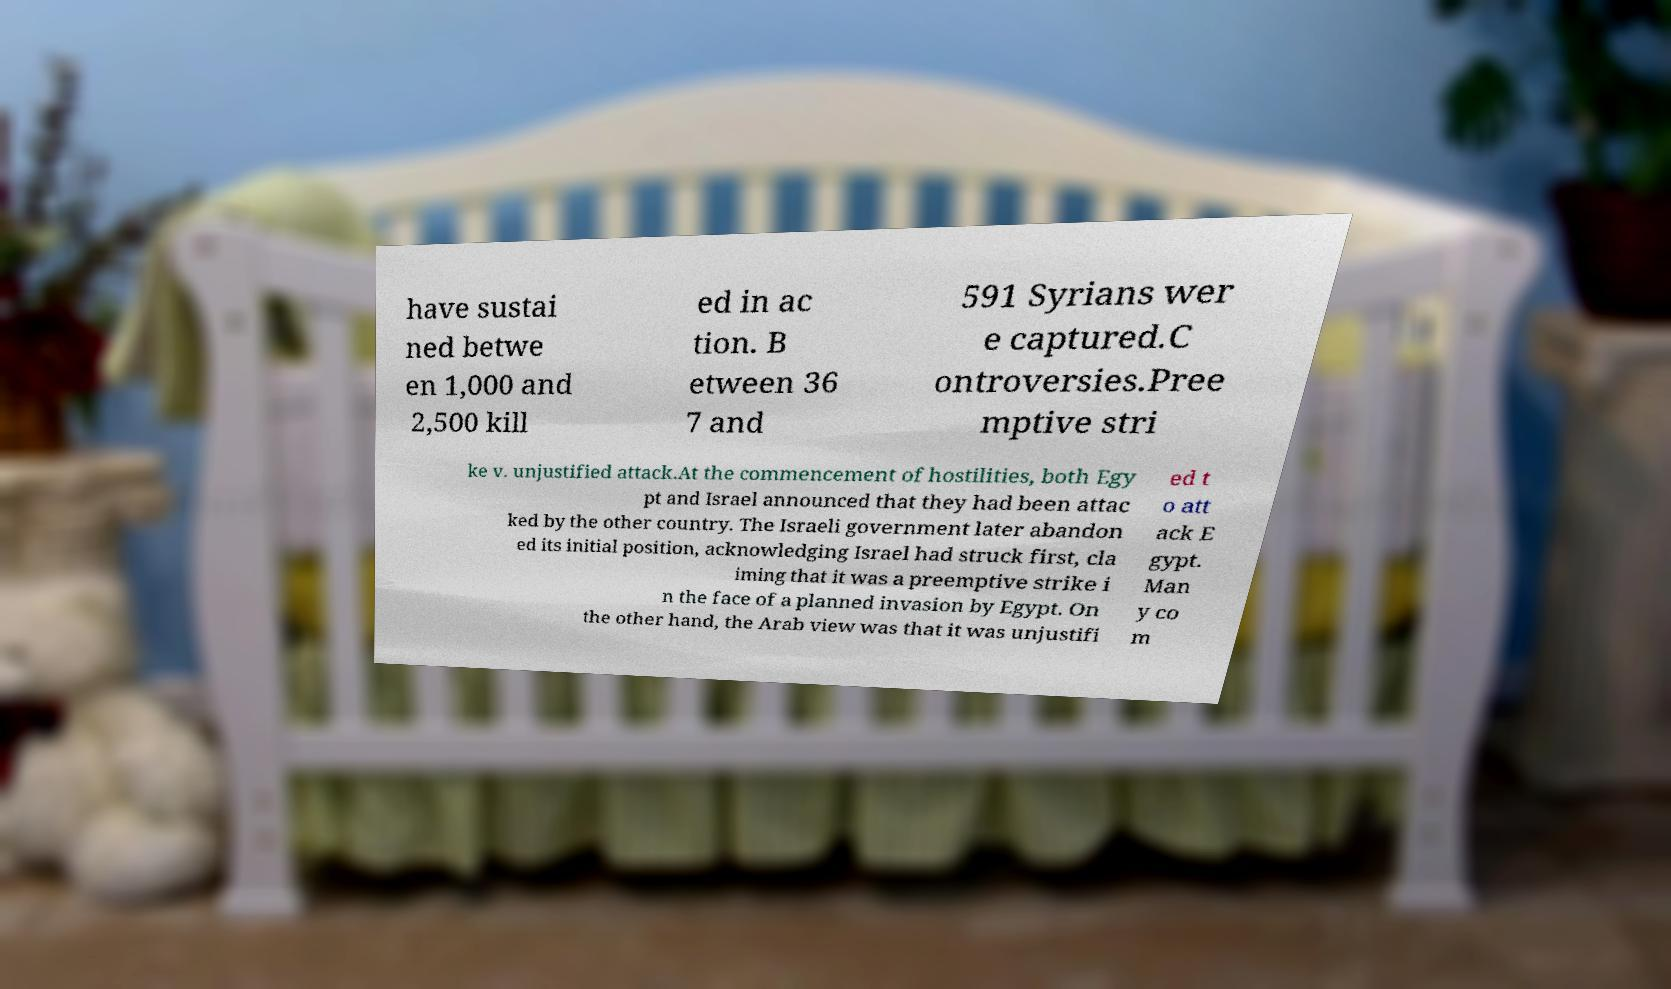Please read and relay the text visible in this image. What does it say? have sustai ned betwe en 1,000 and 2,500 kill ed in ac tion. B etween 36 7 and 591 Syrians wer e captured.C ontroversies.Pree mptive stri ke v. unjustified attack.At the commencement of hostilities, both Egy pt and Israel announced that they had been attac ked by the other country. The Israeli government later abandon ed its initial position, acknowledging Israel had struck first, cla iming that it was a preemptive strike i n the face of a planned invasion by Egypt. On the other hand, the Arab view was that it was unjustifi ed t o att ack E gypt. Man y co m 